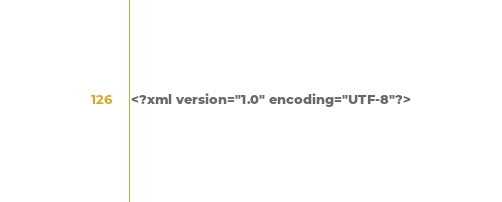Convert code to text. <code><loc_0><loc_0><loc_500><loc_500><_XML_><?xml version="1.0" encoding="UTF-8"?></code> 